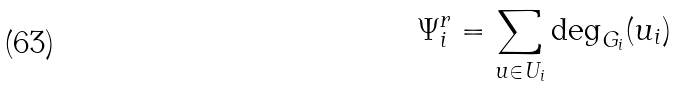<formula> <loc_0><loc_0><loc_500><loc_500>\Psi _ { i } ^ { r } = \sum _ { u \in U _ { i } } \deg _ { G _ { i } } ( u _ { i } )</formula> 